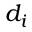<formula> <loc_0><loc_0><loc_500><loc_500>d _ { i }</formula> 